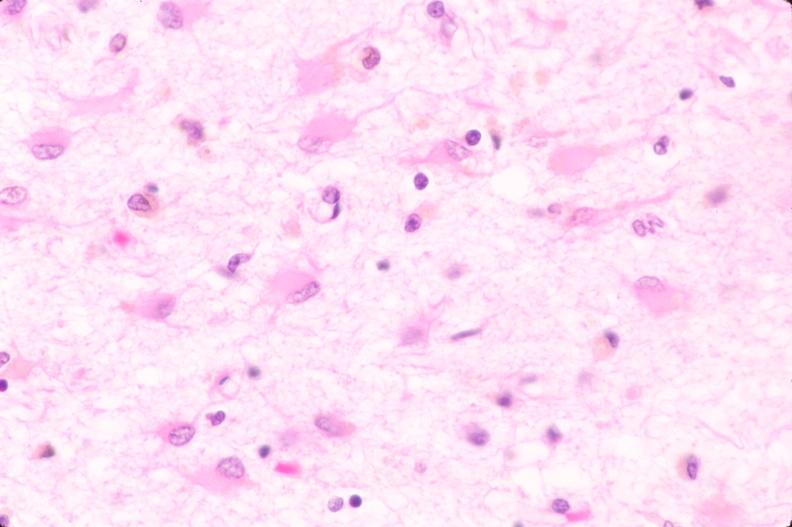s nervous present?
Answer the question using a single word or phrase. Yes 